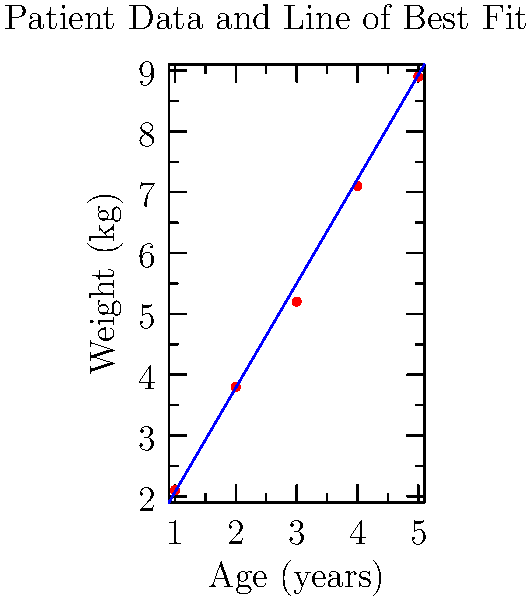Given the patient data points shown in the graph, determine the equation of the line of best fit. Use the least squares method to calculate the slope and y-intercept. Round your final answer to two decimal places. To find the equation of the line of best fit using the least squares method, we'll follow these steps:

1. Calculate the means of x and y:
   $\bar{x} = \frac{1+2+3+4+5}{5} = 3$
   $\bar{y} = \frac{2.1+3.8+5.2+7.1+8.9}{5} = 5.42$

2. Calculate $\sum(x - \bar{x})(y - \bar{y})$ and $\sum(x - \bar{x})^2$:
   $\sum(x - \bar{x})(y - \bar{y}) = (-2)(-3.32) + (-1)(-1.62) + (0)(-0.22) + (1)(1.68) + (2)(3.48) = 17.2$
   $\sum(x - \bar{x})^2 = (-2)^2 + (-1)^2 + 0^2 + 1^2 + 2^2 = 10$

3. Calculate the slope (m):
   $m = \frac{\sum(x - \bar{x})(y - \bar{y})}{\sum(x - \bar{x})^2} = \frac{17.2}{10} = 1.72$

4. Calculate the y-intercept (b):
   $b = \bar{y} - m\bar{x} = 5.42 - 1.72(3) = 0.26$

5. Form the equation of the line:
   $y = mx + b$
   $y = 1.72x + 0.26$

Rounding to two decimal places, we get:
$y = 1.72x + 0.26$
Answer: $y = 1.72x + 0.26$ 